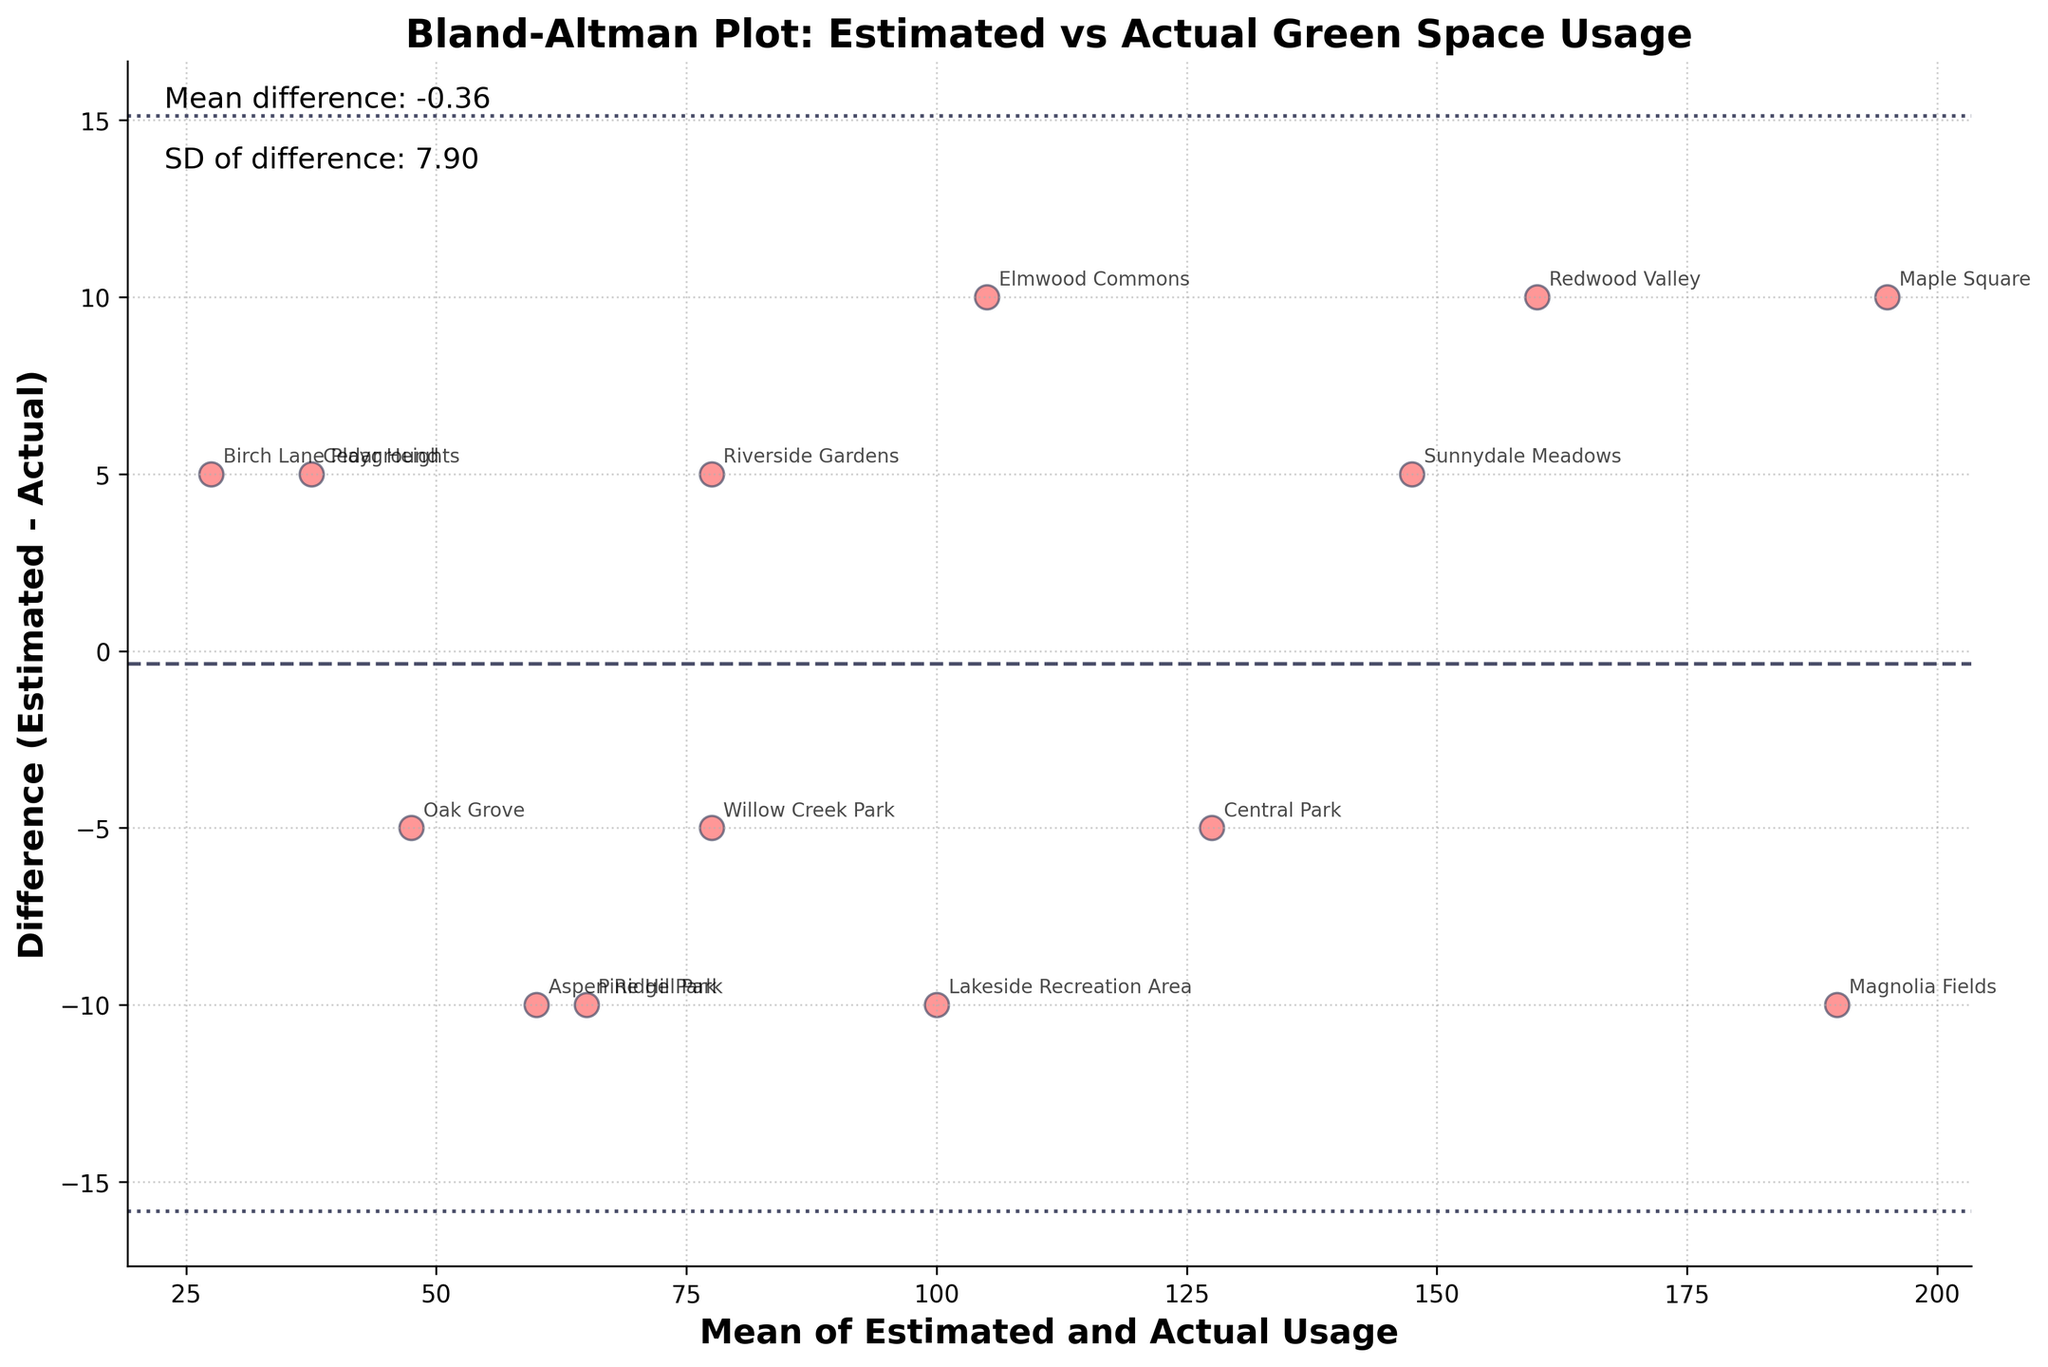What's the title of the plot? The title of the plot is written at the top of the graph.
Answer: Bland-Altman Plot: Estimated vs Actual Green Space Usage What are the labels on the x and y axes? The x-axis and y-axis labels can be found along the respective axis.
Answer: Mean of Estimated and Actual Usage; Difference (Estimated - Actual) How many parks are represented in the plot? Each data point in the plot corresponds to a park. Count the number of data points or annotations.
Answer: 14 What is the color of the data points? Identify the color used to mark the data points in the plot.
Answer: Red What is the mean difference between the estimated and actual usage? The mean difference is indicated by the horizontal dashed line and text noted in the plot.
Answer: 0.14 Which park has the greatest overestimation of green space usage? Look for the park with the highest positive difference (estimated > actual) on the y-axis.
Answer: Cedar Heights Which park has the greatest underestimation of green space usage? Look for the park with the highest negative difference (estimated < actual) on the y-axis.
Answer: Pine Hill Park What are the limits of agreement in the plot? The limits of agreement are 1.96 standard deviations above and below the mean difference, shown as dotted lines.
Answer: -16.82 and 17.10 Is there more overall overestimation or underestimation of green space usage? Assess the distribution of the data points above and below the mean difference line.
Answer: Slight overestimation What is the mean value for Central Park's estimated and actual usage? Find Central Park's annotated point and note its x-position (mean of estimated and actual usage).
Answer: 127.5 